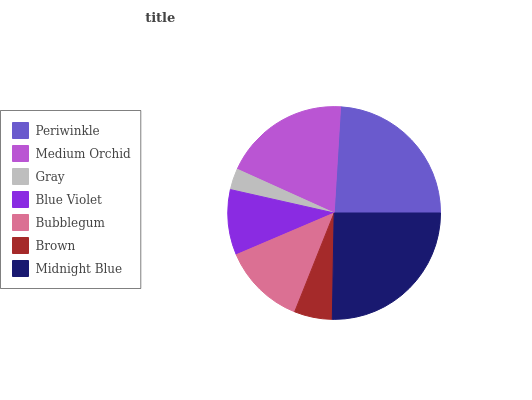Is Gray the minimum?
Answer yes or no. Yes. Is Midnight Blue the maximum?
Answer yes or no. Yes. Is Medium Orchid the minimum?
Answer yes or no. No. Is Medium Orchid the maximum?
Answer yes or no. No. Is Periwinkle greater than Medium Orchid?
Answer yes or no. Yes. Is Medium Orchid less than Periwinkle?
Answer yes or no. Yes. Is Medium Orchid greater than Periwinkle?
Answer yes or no. No. Is Periwinkle less than Medium Orchid?
Answer yes or no. No. Is Bubblegum the high median?
Answer yes or no. Yes. Is Bubblegum the low median?
Answer yes or no. Yes. Is Blue Violet the high median?
Answer yes or no. No. Is Brown the low median?
Answer yes or no. No. 